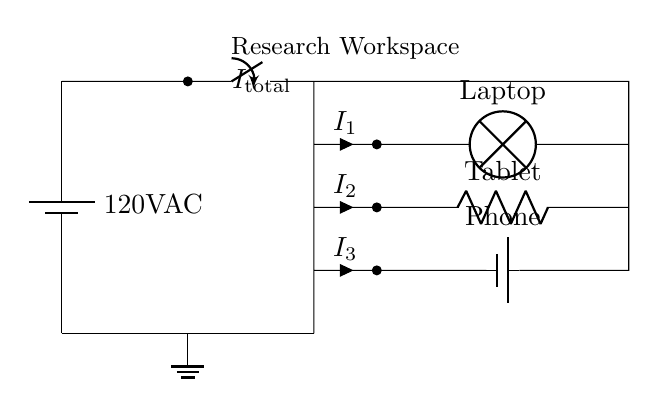What is the voltage of the circuit? The voltage is 120V AC, as indicated by the power source labeled in the circuit diagram.
Answer: 120V AC What types of devices are used in the circuit? The circuit contains a laptop, tablet, and phone, which are labeled next to each device in the diagram.
Answer: Laptop, tablet, phone How many branches are there in this parallel circuit? There are three branches represented in the circuit, each connected to different devices: one for the laptop, one for the tablet, and one for the phone.
Answer: Three What is the total current in the circuit? The total current symbol is labeled as Itotal above the main connections, but the actual value is not provided; it represents the sum of the currents in all branches.
Answer: Itotal Which component is used to charge the phone? A battery is connected for the phone, indicating that this device is specifically designed for charging.
Answer: Battery Which device draws the most current? The laptop is commonly known to consume more power than the other devices, but specific current values (I1, I2, and I3) are not given to determine exact values in this diagram.
Answer: Laptop What function does the switch serve in this circuit? The switch allows for the control of the entire circuit by either enabling or disabling the flow of electricity to all connected branches at once.
Answer: Control 